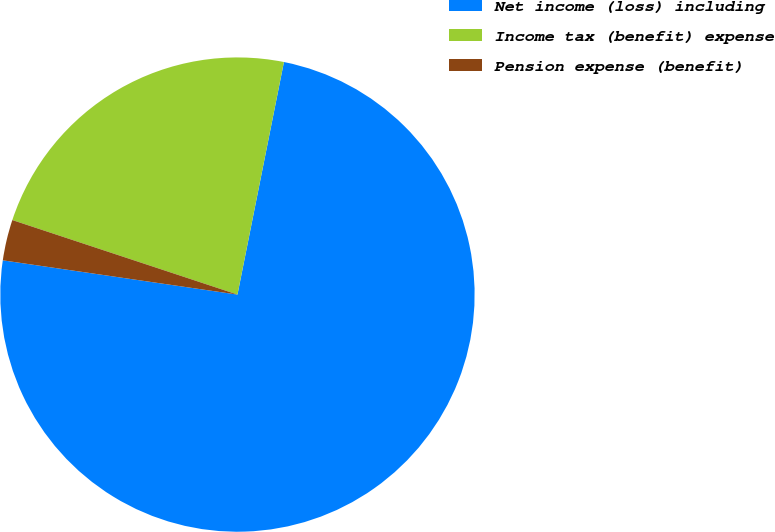<chart> <loc_0><loc_0><loc_500><loc_500><pie_chart><fcel>Net income (loss) including<fcel>Income tax (benefit) expense<fcel>Pension expense (benefit)<nl><fcel>74.16%<fcel>23.05%<fcel>2.78%<nl></chart> 